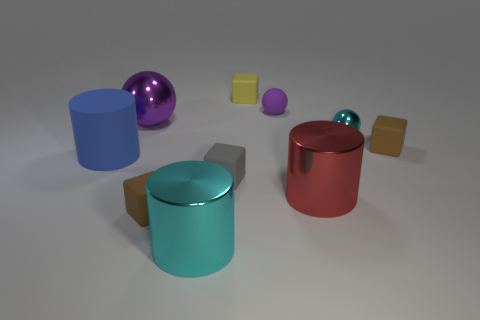What material is the big cylinder that is the same color as the small metal ball?
Your answer should be very brief. Metal. What material is the purple thing that is the same size as the red thing?
Provide a succinct answer. Metal. Are the small cyan ball and the red object made of the same material?
Offer a very short reply. Yes. How many objects are either green matte objects or gray blocks?
Provide a short and direct response. 1. What shape is the small brown thing that is in front of the matte cylinder?
Your answer should be very brief. Cube. There is another big sphere that is made of the same material as the cyan ball; what is its color?
Offer a terse response. Purple. What is the material of the small purple thing that is the same shape as the large purple thing?
Make the answer very short. Rubber. What shape is the tiny yellow thing?
Your response must be concise. Cube. There is a cylinder that is both behind the large cyan object and in front of the tiny gray cube; what is its material?
Your response must be concise. Metal. There is a gray thing that is the same material as the small yellow thing; what is its shape?
Offer a very short reply. Cube. 